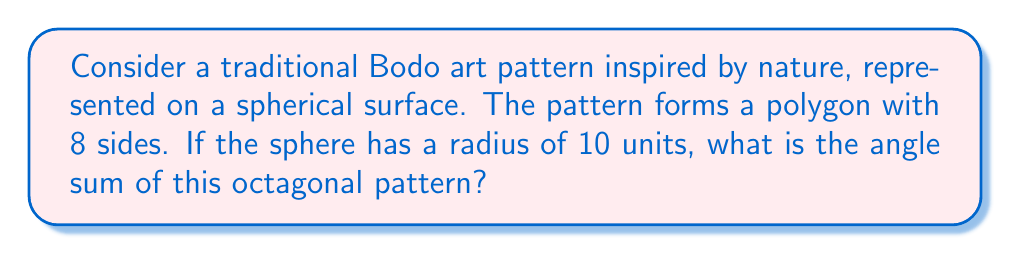Solve this math problem. To solve this problem, we'll follow these steps:

1) In non-Euclidean geometry on a sphere, the angle sum of a polygon is different from that in Euclidean geometry. The formula for the angle sum (S) of a polygon with n sides on a sphere is:

   $$S = (n-2)\pi + \frac{A}{R^2}$$

   where A is the area of the polygon and R is the radius of the sphere.

2) For a sphere of radius R, the total surface area is $4\pi R^2$.

3) The area of our octagon (A) can be expressed as a fraction of the total surface area. Let's assume it covers 1/4 of the sphere's surface:

   $$A = \frac{1}{4} \cdot 4\pi R^2 = \pi R^2$$

4) Now, let's substitute our values into the formula:
   n = 8 (octagon)
   R = 10 units
   A = $\pi R^2 = \pi \cdot 10^2 = 100\pi$

   $$S = (8-2)\pi + \frac{100\pi}{10^2}$$

5) Simplify:
   $$S = 6\pi + \pi = 7\pi$$

6) Convert to degrees:
   $$S = 7\pi \cdot \frac{180°}{\pi} = 1260°$$

Thus, the angle sum of the octagonal pattern on this spherical surface is 1260°.
Answer: 1260° 